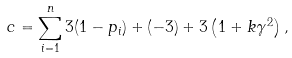Convert formula to latex. <formula><loc_0><loc_0><loc_500><loc_500>c = \sum _ { i = 1 } ^ { n } 3 ( 1 - p _ { i } ) + ( - 3 ) + 3 \left ( 1 + k \gamma ^ { 2 } \right ) ,</formula> 